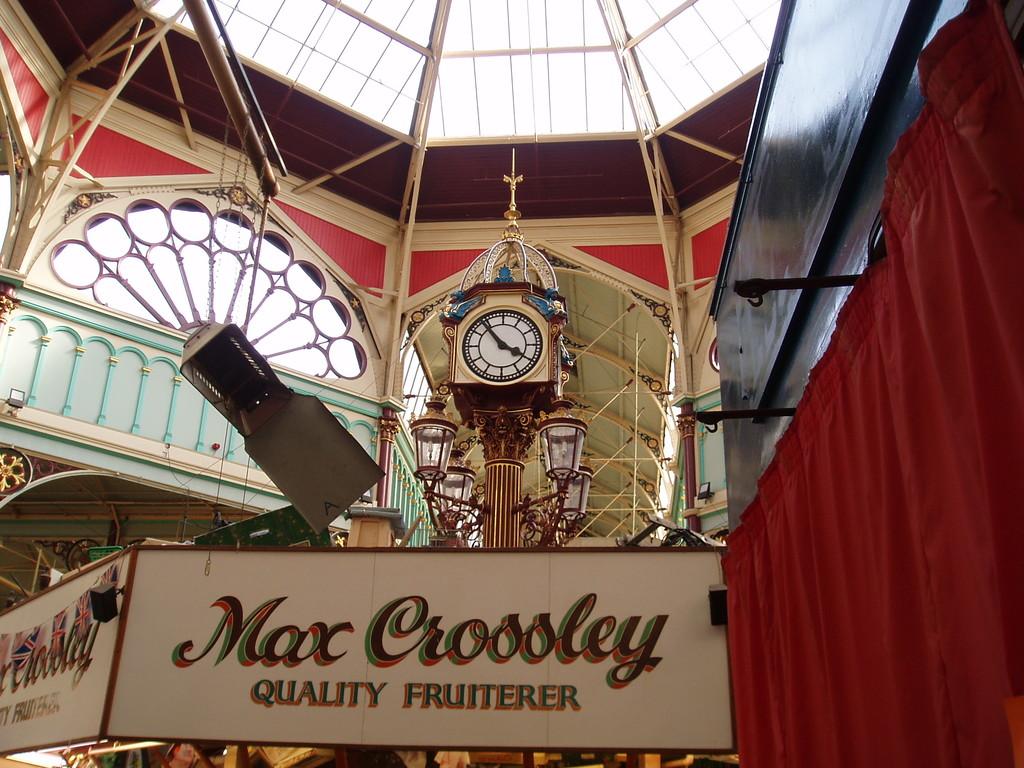What time is shown on the fancy clock?
Your answer should be very brief. 3:55. What is the name on the billboard?
Make the answer very short. Max crossley. 